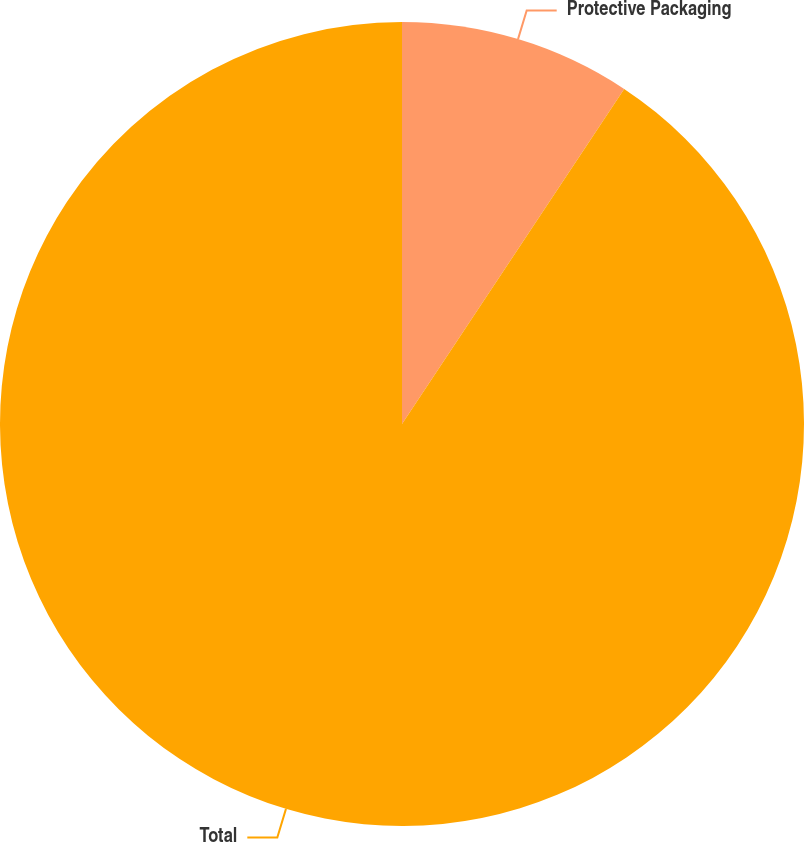<chart> <loc_0><loc_0><loc_500><loc_500><pie_chart><fcel>Protective Packaging<fcel>Total<nl><fcel>9.32%<fcel>90.68%<nl></chart> 